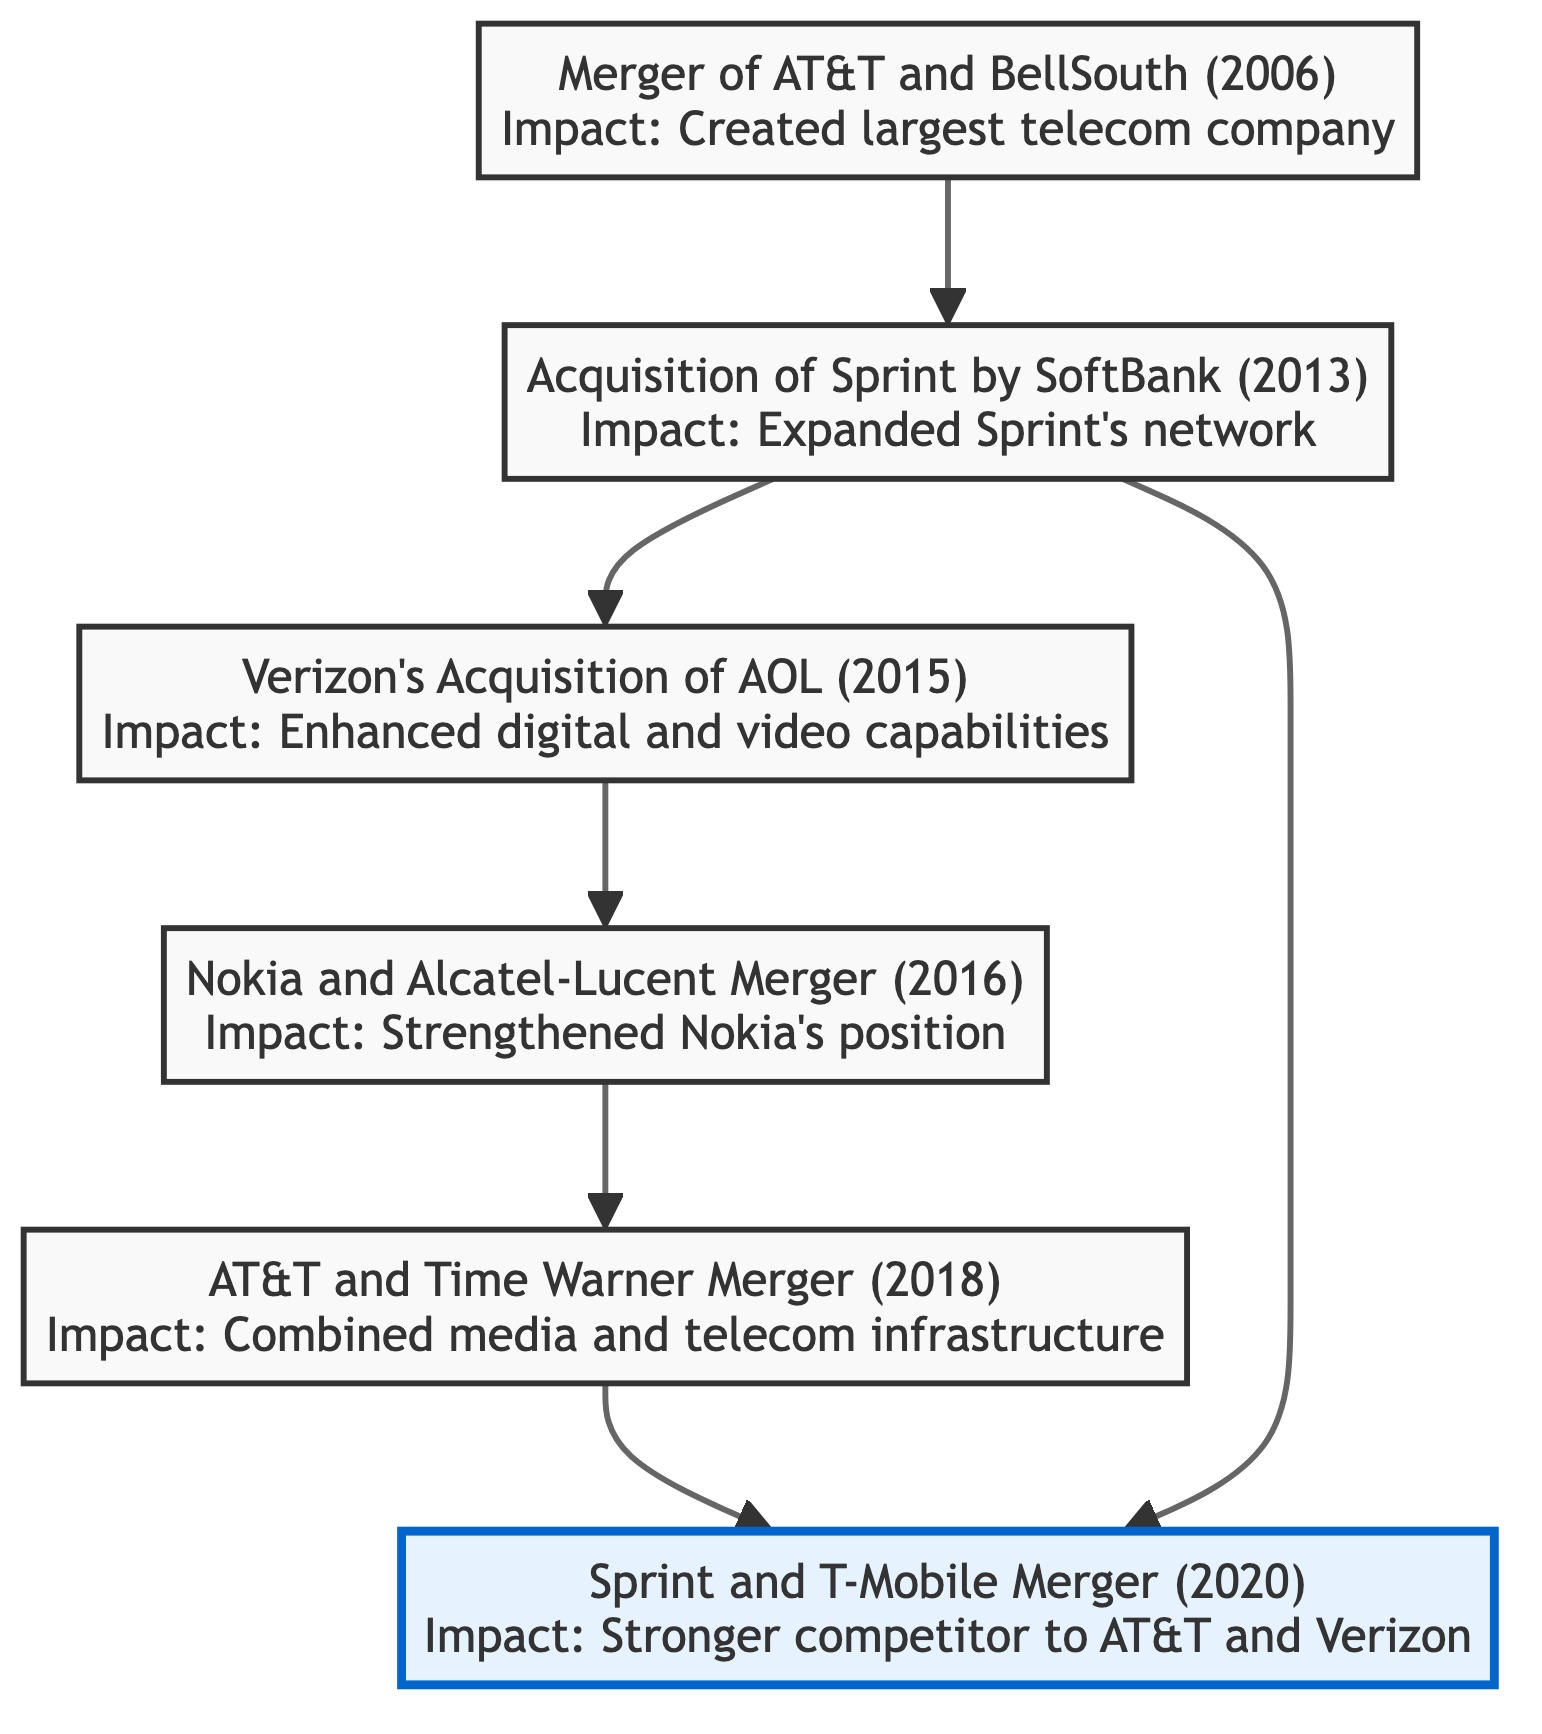What is the earliest merger represented in the diagram? The earliest merger listed in the diagram is the Merger of AT&T and BellSouth, which took place in 2006. This is identified as the first node at the bottom of the flowchart.
Answer: Merger of AT&T and BellSouth (2006) How many mergers are shown in the diagram? The diagram features six key mergers and acquisitions, as each node represents one of these events. Counting from the bottom node to the top node confirms this total.
Answer: 6 Which acquisition is directly linked to the acquisition of Sprint by SoftBank? The Sprint and T-Mobile Merger is directly linked to the Acquisition of Sprint by SoftBank, as it follows it in the flow. This is indicated by the directional connection from node E to node A.
Answer: Sprint and T-Mobile Merger What impact did the 2013 acquisition of Sprint have on the company? The acquisition enabled Sprint to expand its network and better compete against larger firms like Verizon and AT&T, which is noted in its description.
Answer: Expanded Sprint's network Which merger has the most recent date? The most recent event in the diagram is the Sprint and T-Mobile Merger, which occurred in 2020, as it is the highest node in the flowchart.
Answer: Sprint and T-Mobile Merger (2020) How many mergers are initiated by AT&T in the diagram? There are two mergers initiated by AT&T: the Merger of AT&T and BellSouth in 2006 and the AT&T and Time Warner Merger in 2018. This can be determined by counting the relevant nodes connected to AT&T.
Answer: 2 What is the impact of Verizon's acquisition of AOL? The impact detailed in the diagram for Verizon's acquisition of AOL is that it enhanced Verizon’s digital and video content capabilities. This is clearly stated under the respective node.
Answer: Enhanced digital and video capabilities Which merger created the largest telecommunications company at the time? The Merger of AT&T and BellSouth created the largest telecommunications company at the time, as stated in its impact description in the diagram.
Answer: Created largest telecommunications company What does the flow from the Acquisition of Sprint by SoftBank lead to? The flow from the Acquisition of Sprint by SoftBank leads to two nodes: Verizon’s Acquisition of AOL and the Sprint and T-Mobile Merger, indicating its importance in the subsequent developments.
Answer: Sprint and T-Mobile Merger, Verizon's Acquisition of AOL 